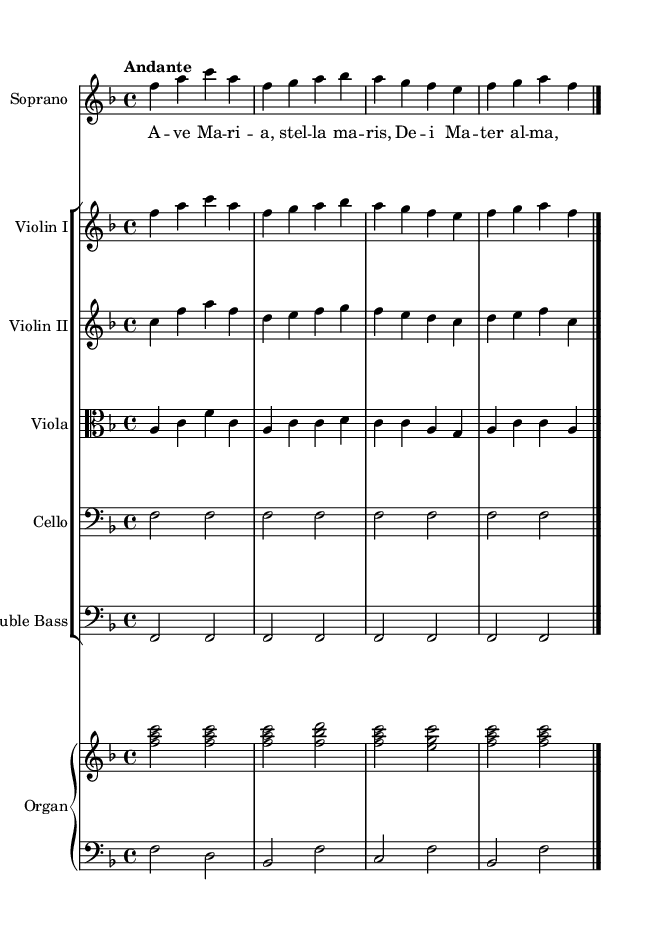What is the key signature of this music? The key signature is F major, which has one flat (B flat). This can be determined by looking for the flat symbol at the beginning of the staff.
Answer: F major What is the time signature of this music? The time signature is 4/4, indicated at the beginning of the score with two numbers, where the top number represents the number of beats in a measure and the bottom number denotes the note value that receives one beat.
Answer: 4/4 What is the tempo marking of this music? The tempo marking is "Andante," which is placed above the staff and indicates a moderate walking pace. It suggests the speed at which the music should be played.
Answer: Andante How many staff lines are used for the organ in this music? There are two staff lines used for the organ, indicated by the "PianoStaff" in the score, which shows both the treble (right) and bass (left) clefs stacked together.
Answer: Two What voice type is featured in this piece? The voice type featured in this piece is Soprano, identified in the header and noted by the specific staff labeled "Soprano."
Answer: Soprano What is the role of the double bass in this score? The double bass provides harmonic foundation and low melodic support, indicated by its inclusion in the orchestration, and its notes align with half notes sustaining the bass line throughout the piece.
Answer: Harmonic foundation How does the lyrical content relate to Catholic traditions? The lyrical content includes the phrase "Ave Maria," which is a traditional Catholic prayer and reflects the religious themes aligned with Catholic feast days. This indicates the piece's purpose in celebrating those traditions.
Answer: Catholic prayer 